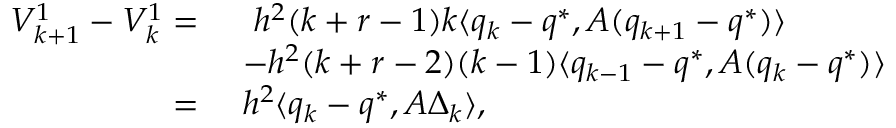Convert formula to latex. <formula><loc_0><loc_0><loc_500><loc_500>\begin{array} { r l } { V _ { k + 1 } ^ { 1 } - V _ { k } ^ { 1 } = \ } & { \ h ^ { 2 } ( k + r - 1 ) k \langle q _ { k } - q ^ { * } , A ( q _ { k + 1 } - q ^ { * } ) \rangle } \\ & { - h ^ { 2 } ( k + r - 2 ) ( k - 1 ) \langle q _ { k - 1 } - q ^ { * } , A ( q _ { k } - q ^ { * } ) \rangle } \\ { = \ } & { h ^ { 2 } \langle q _ { k } - q ^ { * } , A \Delta _ { k } \rangle , } \end{array}</formula> 